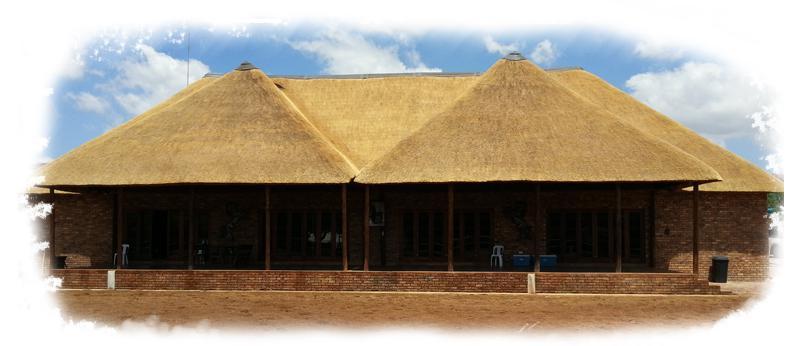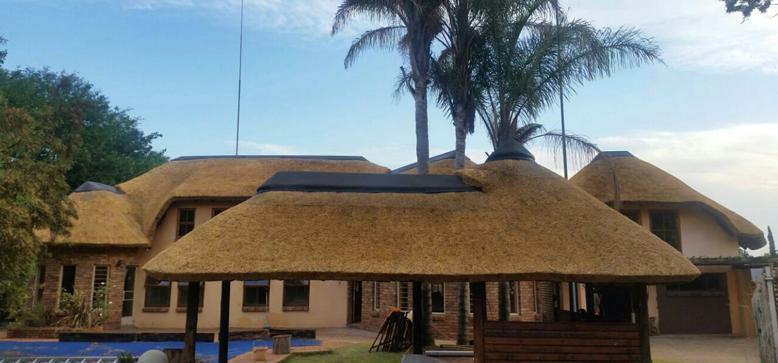The first image is the image on the left, the second image is the image on the right. Examine the images to the left and right. Is the description "The right image shows a roof made of plant material draped over leafless tree supports with forked limbs." accurate? Answer yes or no. No. The first image is the image on the left, the second image is the image on the right. For the images shown, is this caption "The vertical posts are real tree trunks." true? Answer yes or no. No. 